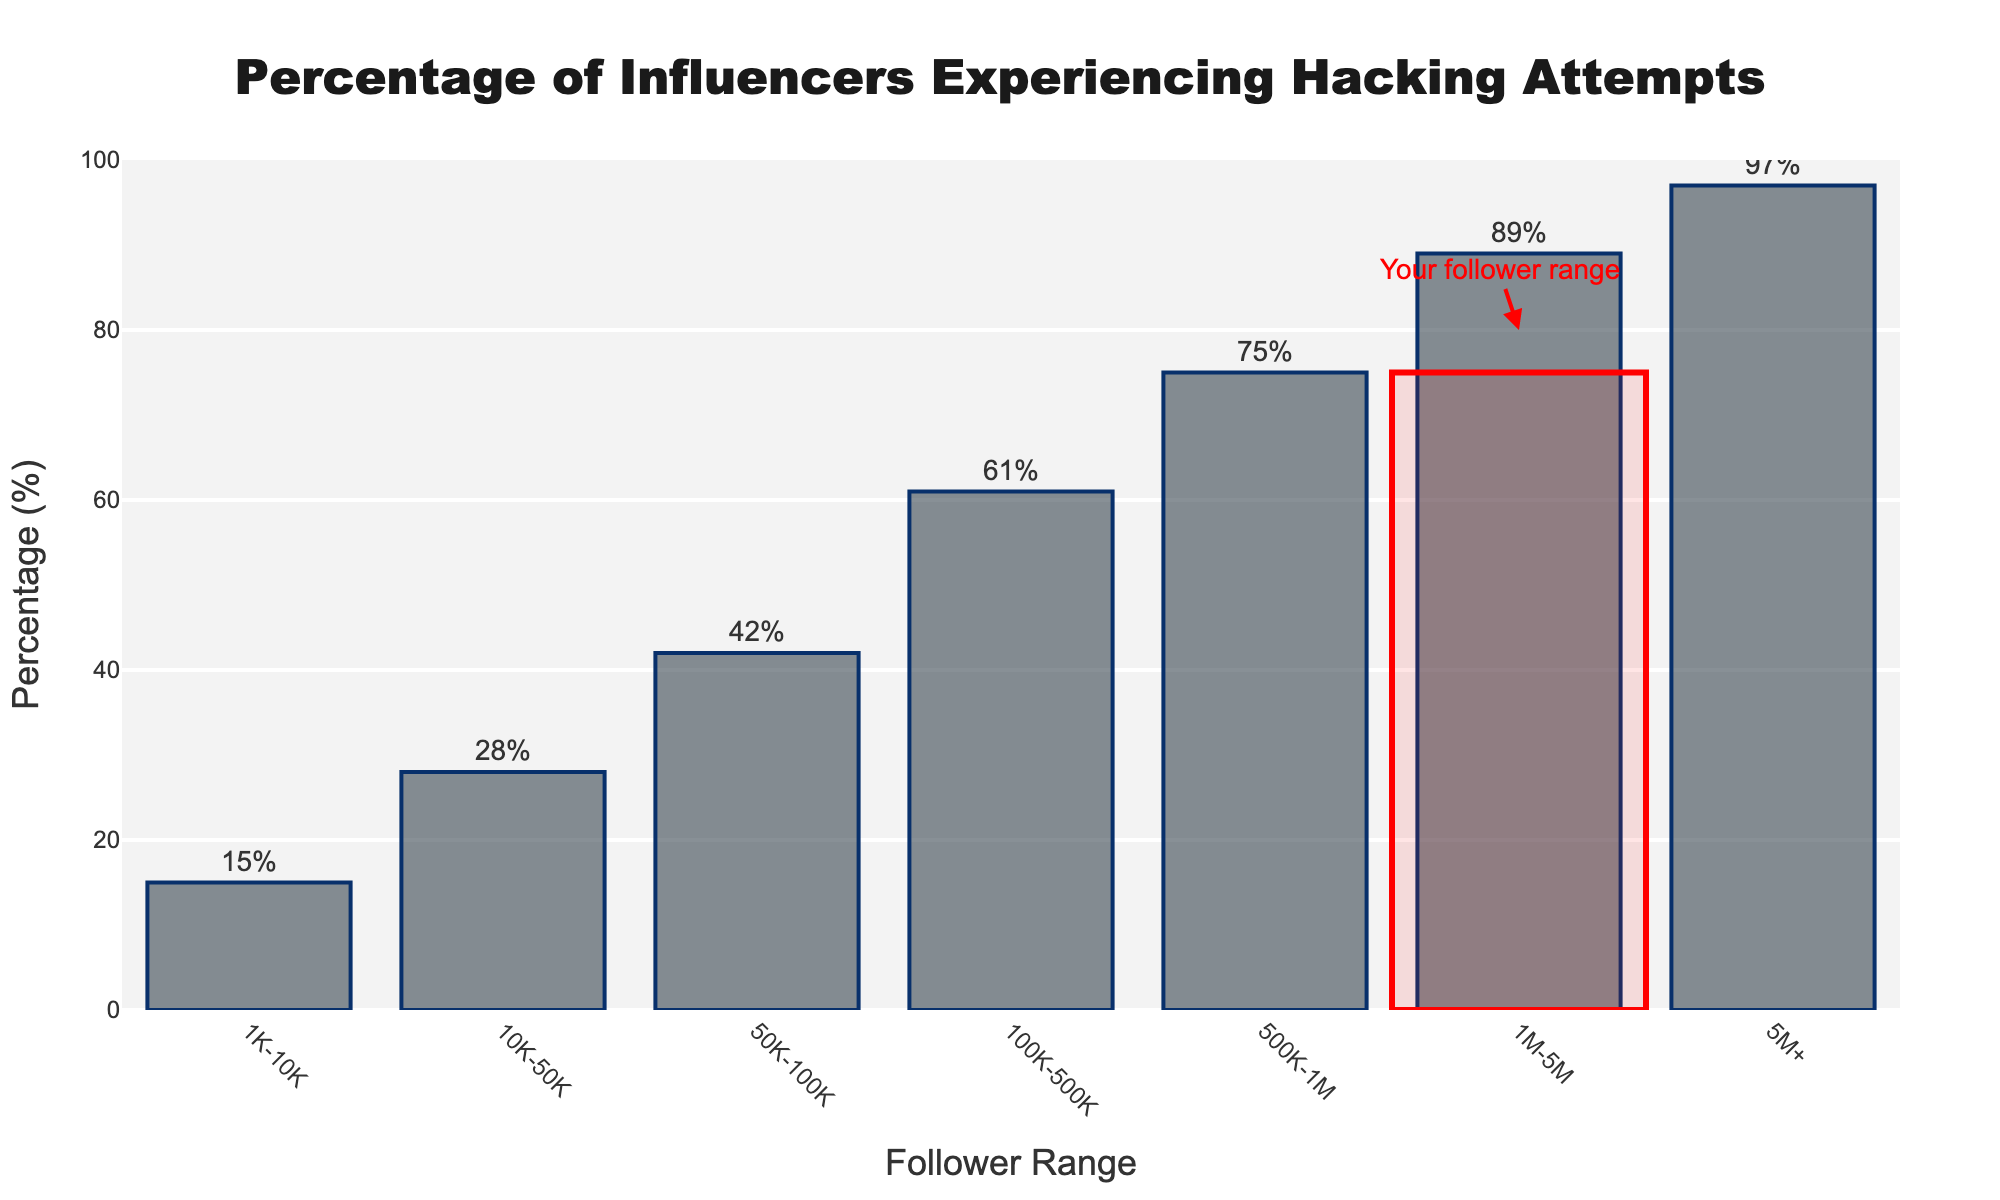What is the percentage of influencers with 100K-500K followers who have experienced hacking attempts? The bar for the 100K-500K follower range is labeled with a percentage of 61%, indicating that 61% of influencers in this range have experienced hacking attempts.
Answer: 61% Which follower range has the highest percentage of influencers who have experienced hacking attempts, and what is this percentage? The bar for the 5M+ follower range reaches the highest point with 97%, indicating that this range has the highest percentage of influencers who have experienced hacking attempts.
Answer: 5M+, 97% How does the percentage of influencers experiencing hacking attempts change from 1M-5M followers to 5M+ followers? The bar representing the 1M-5M follower range shows 89%, and the bar for the 5M+ range shows 97%, so the change is 97% - 89% = 8%.
Answer: 8% Compare the percentage of influencers who have experienced hacking attempts between the 10K-50K and 50K-100K follower ranges. The bar for the 10K-50K range shows 28%, while the bar for the 50K-100K range shows 42%, indicating a difference of 42% - 28% = 14%.
Answer: 14% What is the visual difference between the follower range marked as "Your follower range" and the previous one (50K-100K)? The bars show that the percentage for 100K-500K (your follower range) is 61%, while the previous one (50K-100K) is 42%. Visually, the bar for 100K-500K is taller and highlighted with a red box. The difference in percentage is 61% - 42% = 19%.
Answer: 19% What is the overall trend of the percentage of influencers experiencing hacking attempts as follower count increases? Observing the bars from left to right, the percentage of influencers experiencing hacking attempts consistently increases from 15% for 1K-10K followers to 97% for 5M+ followers, indicating an upward trend.
Answer: Increases By how much does the percentage of influencers experiencing hacking attempts increase from the 1K-10K to the 500K-1M follower range? The bar for the 1K-10K range shows 15%, and the 500K-1M range shows 75%. The increase is 75% - 15% = 60%.
Answer: 60% Is there a significant increase in the percentage of influencers experiencing hacking attempts between any consecutive follower ranges? The biggest jump is seen between the 100K-500K range (61%) and the 500K-1M range (75%), which is an increase of 75% - 61% = 14%.
Answer: 14% What's the average percentage of influencers experiencing hacking attempts for follower ranges below 1M? The percentages for the ranges below 1M are 15%, 28%, 42%, 61%, and 75%. Adding these percentages: 15% + 28% + 42% + 61% + 75% = 221%. Dividing by the number of ranges (5): 221% / 5 = 44.2%.
Answer: 44.2% How much higher is the percentage of hacking attempts for influencers with 10K-50K followers compared to those with 1K-10K followers? The percentage for the 10K-50K range is 28%, and for the 1K-10K range, it is 15%. The difference is 28% - 15% = 13%.
Answer: 13% 